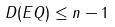<formula> <loc_0><loc_0><loc_500><loc_500>D ( E Q ) \leq n - 1</formula> 